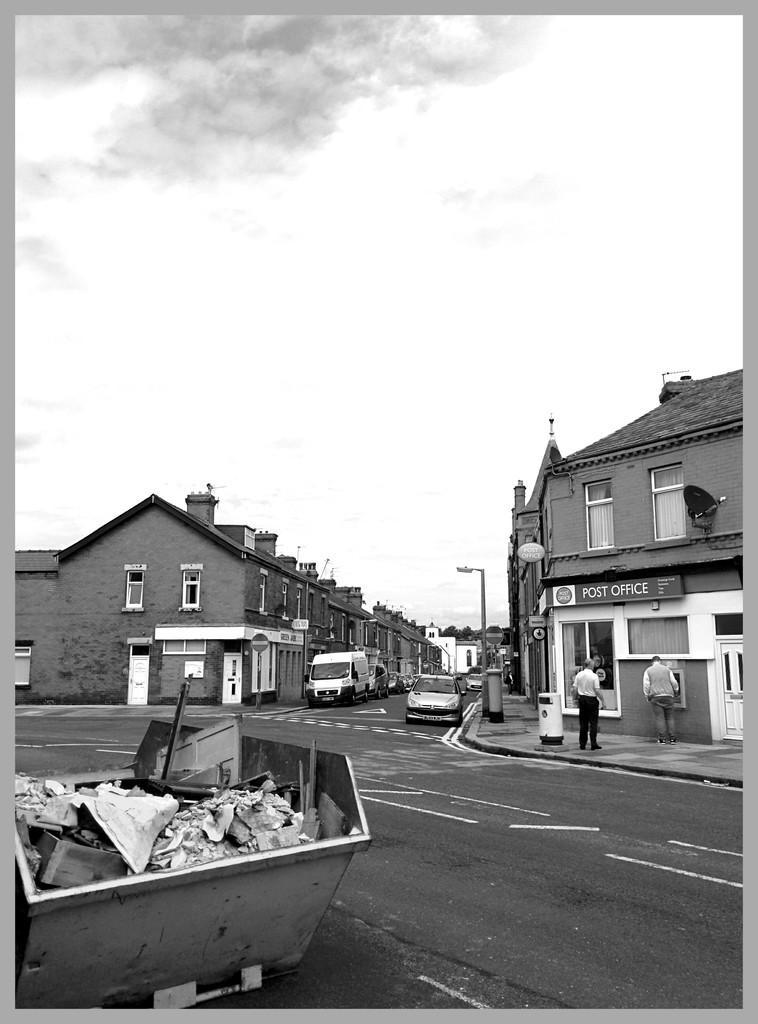How would you summarize this image in a sentence or two? In this picture we can see a cart with garbage in it and in the background we can see vehicles, people on the road and we can see buildings, sky. 